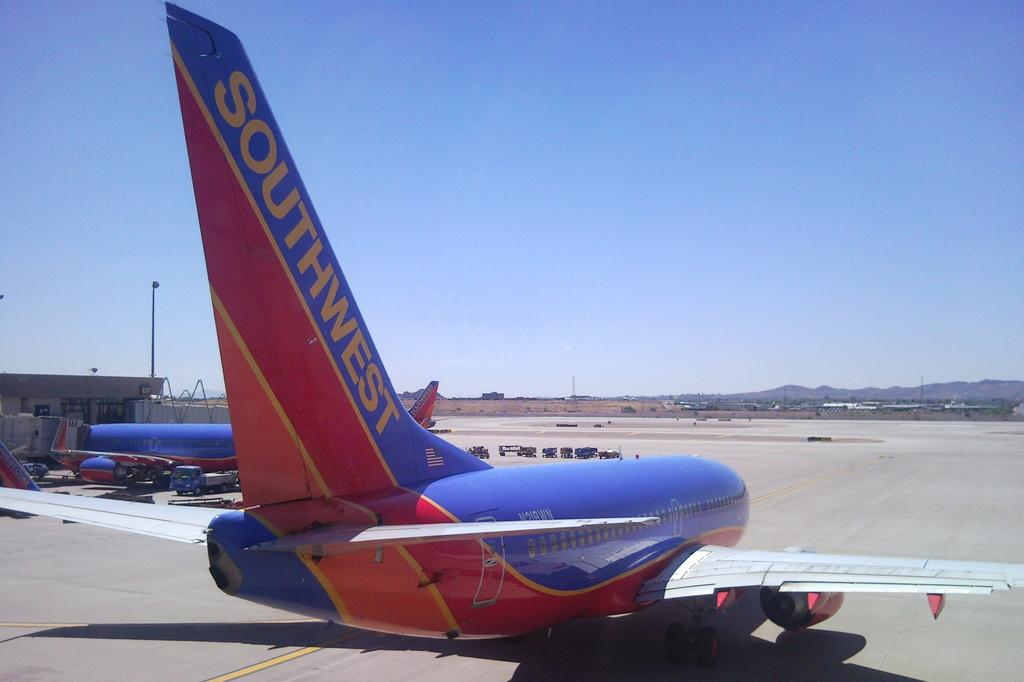<image>
Present a compact description of the photo's key features. Airplane that is southwest is landed on the ground 